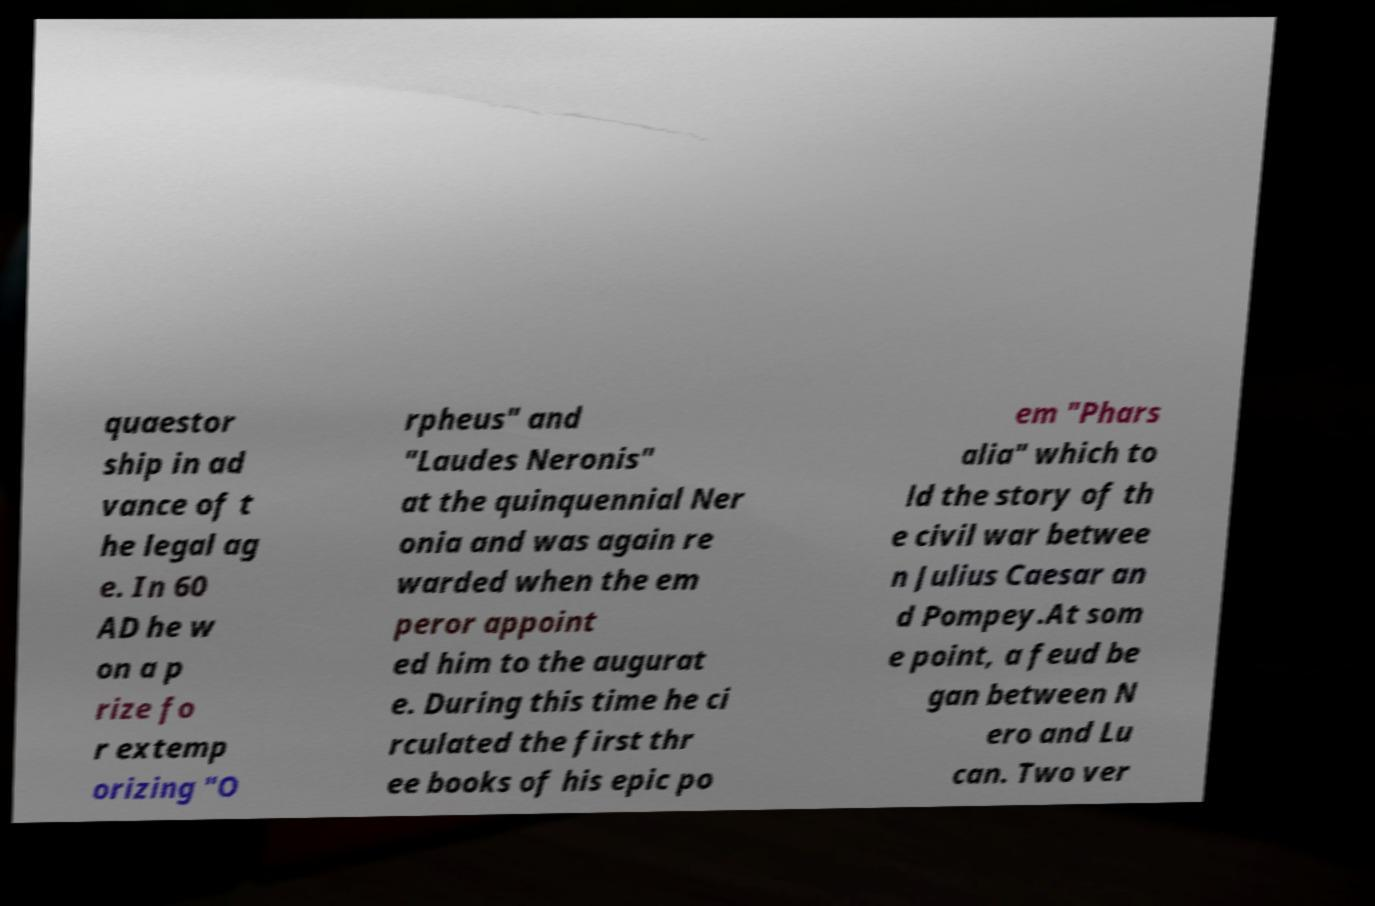What messages or text are displayed in this image? I need them in a readable, typed format. quaestor ship in ad vance of t he legal ag e. In 60 AD he w on a p rize fo r extemp orizing "O rpheus" and "Laudes Neronis" at the quinquennial Ner onia and was again re warded when the em peror appoint ed him to the augurat e. During this time he ci rculated the first thr ee books of his epic po em "Phars alia" which to ld the story of th e civil war betwee n Julius Caesar an d Pompey.At som e point, a feud be gan between N ero and Lu can. Two ver 